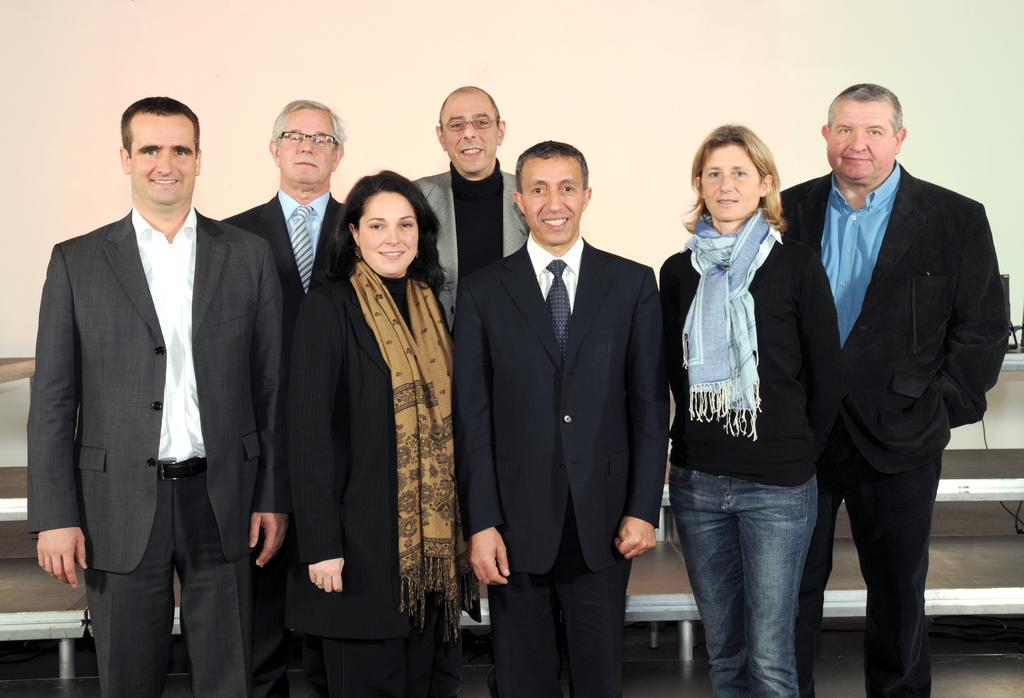How many people are in the image? There is a group of people in the image. What is the position of the people in the image? The people are standing on the floor. What type of clothing can be seen on some of the people? Some of the people are wearing coats and ties. What can be seen in the background of the image? There are benches and a wall visible in the background of the image. What is the reason for the drawer being open in the image? There is no drawer present in the image; it only features a group of people standing on the floor, with some wearing coats and ties, and a background that includes benches and a wall. 